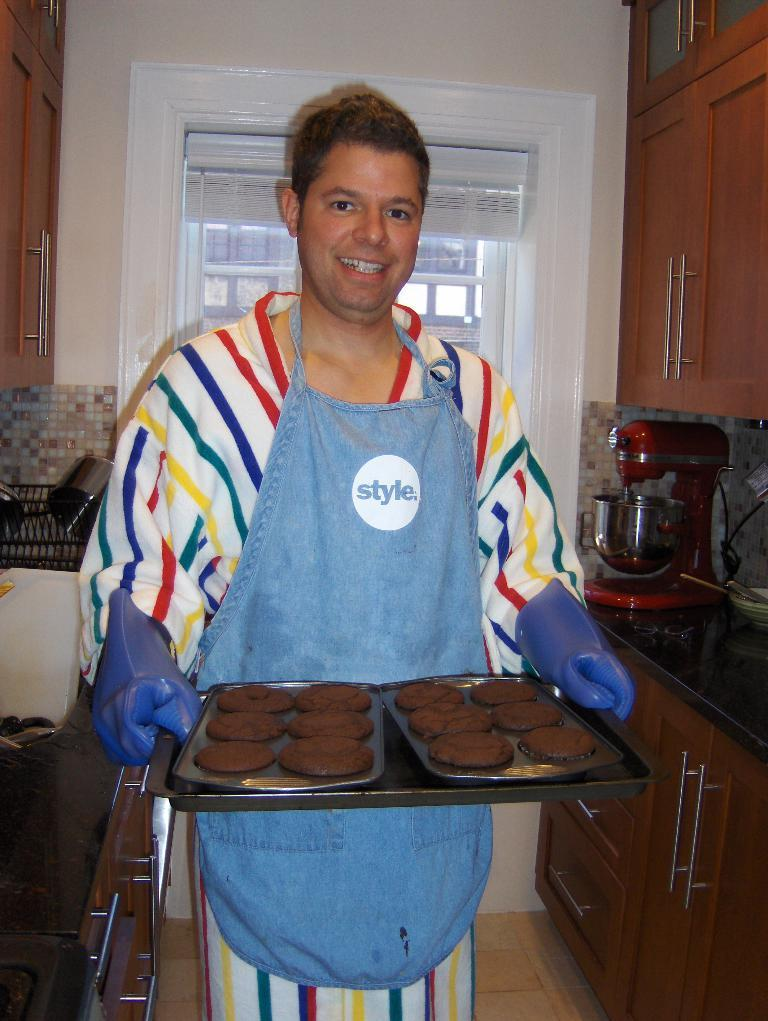<image>
Render a clear and concise summary of the photo. A smiling man, holding a tray, wearing a blue apron with "style" printed on front. 